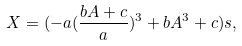<formula> <loc_0><loc_0><loc_500><loc_500>X = ( - a ( \frac { b A + c } { a } ) ^ { 3 } + b A ^ { 3 } + c ) s ,</formula> 